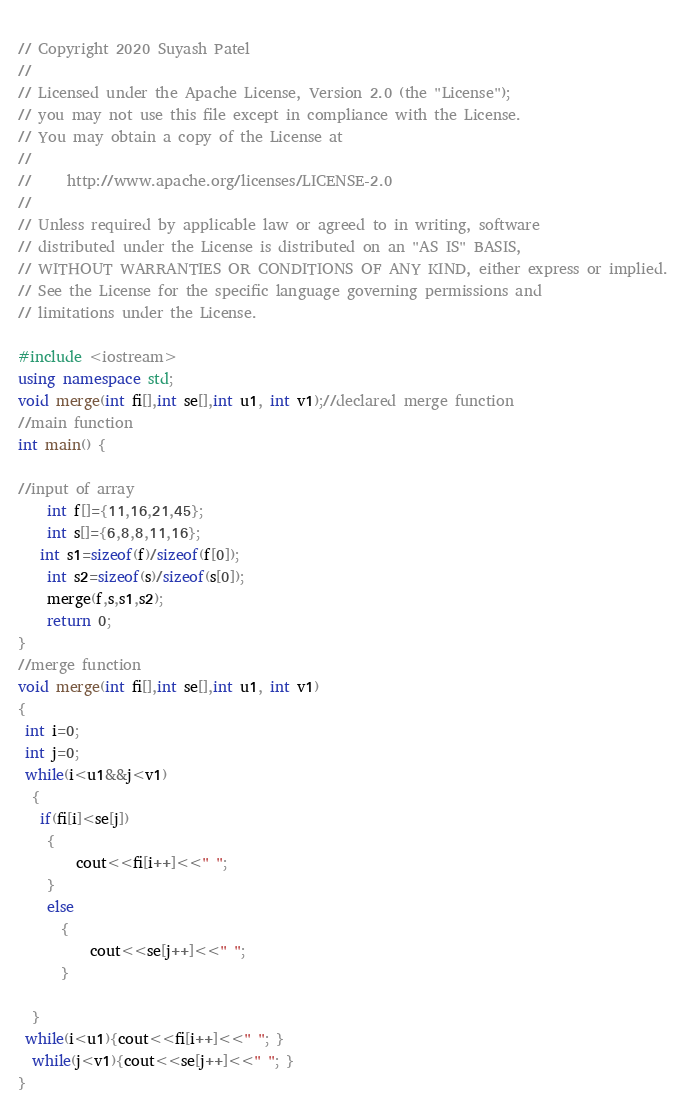Convert code to text. <code><loc_0><loc_0><loc_500><loc_500><_C++_>  
// Copyright 2020 Suyash Patel
//
// Licensed under the Apache License, Version 2.0 (the "License");
// you may not use this file except in compliance with the License.
// You may obtain a copy of the License at
//
//     http://www.apache.org/licenses/LICENSE-2.0
//
// Unless required by applicable law or agreed to in writing, software
// distributed under the License is distributed on an "AS IS" BASIS,
// WITHOUT WARRANTIES OR CONDITIONS OF ANY KIND, either express or implied.
// See the License for the specific language governing permissions and
// limitations under the License.

#include <iostream>
using namespace std;
void merge(int fi[],int se[],int u1, int v1);//declared merge function
//main function
int main() {

//input of array
    int f[]={11,16,21,45};
    int s[]={6,8,8,11,16};
   int s1=sizeof(f)/sizeof(f[0]);
    int s2=sizeof(s)/sizeof(s[0]);
	merge(f,s,s1,s2);
	return 0;
}
//merge function
void merge(int fi[],int se[],int u1, int v1)
{
 int i=0;
 int j=0;
 while(i<u1&&j<v1)
  {
   if(fi[i]<se[j])
    {
        cout<<fi[i++]<<" ";
    }
    else
      {
          cout<<se[j++]<<" ";
      }
 
  }
 while(i<u1){cout<<fi[i++]<<" "; }
  while(j<v1){cout<<se[j++]<<" "; }
}
</code> 